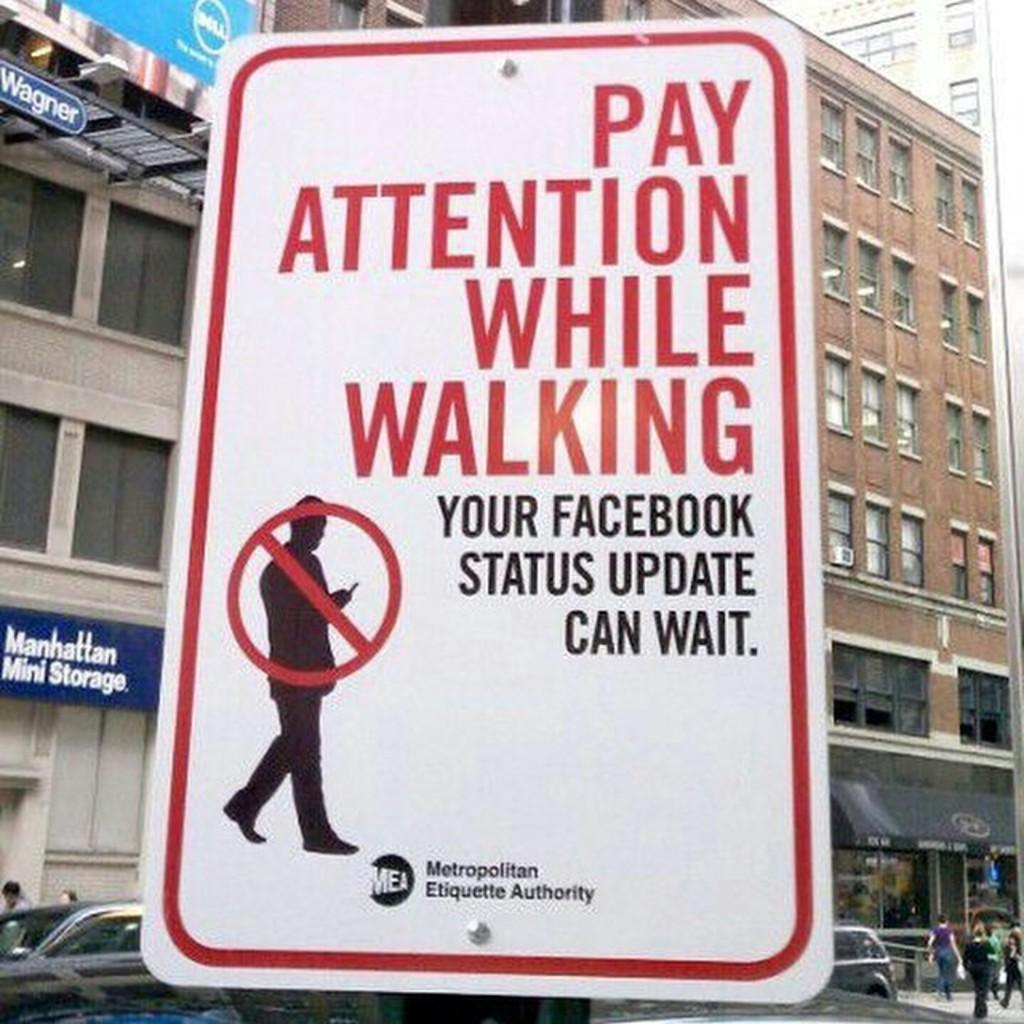<image>
Write a terse but informative summary of the picture. A sign saying pay attention while walking is posted 